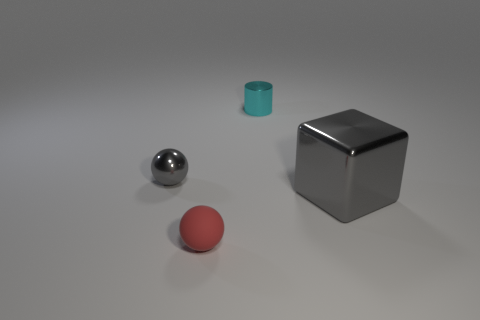What number of other things are there of the same shape as the large thing?
Your response must be concise. 0. Is the number of gray metallic things that are behind the big gray thing less than the number of yellow rubber balls?
Give a very brief answer. No. What is the material of the tiny thing behind the tiny gray metallic ball?
Give a very brief answer. Metal. What number of other objects are the same size as the gray ball?
Your response must be concise. 2. Are there fewer big cubes than large green cylinders?
Your response must be concise. No. The big thing has what shape?
Make the answer very short. Cube. Is the color of the shiny thing to the right of the cylinder the same as the tiny rubber thing?
Your answer should be compact. No. There is a object that is both in front of the small gray shiny sphere and right of the matte object; what is its shape?
Give a very brief answer. Cube. There is a tiny sphere behind the large gray block; what is its color?
Keep it short and to the point. Gray. Is there any other thing that has the same color as the metallic cylinder?
Make the answer very short. No. 